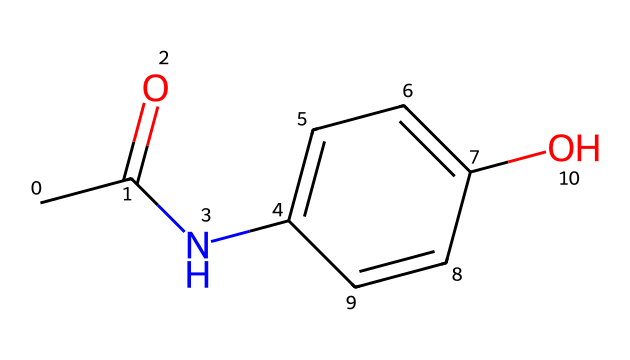What is the molecular formula of this compound? The molecular formula can be determined by counting the number of each type of atom in the SMILES representation. The structure contains 9 carbon atoms, 9 hydrogen atoms, 1 nitrogen atom, and 1 oxygen atom. Therefore, the molecular formula is C9H9NO.
Answer: C9H9NO How many rings are present in the structure? To identify rings, one must look for atoms connected to form a closed loop in the structure. The structure shows one six-membered aromatic ring indicated by the presence of alternating double bonds in the carbon chain. Therefore, there is one ring.
Answer: 1 What type of functional groups are present in this molecule? By analyzing the structure, one can identify the functional groups: there is an amide functional group (from the -NC=O part) and a phenolic hydroxyl group (from the -OH attachment). Hence, the functional groups present are an amide and a phenol.
Answer: amide and phenol What is the predicted solubility of this drug in water? The presence of the hydroxyl group (phenolic) typically increases solubility in polar solvents like water. However, the lipophilic alkyl portion may reduce it somewhat, though due to the hydroxyl group, it is still expected to be moderately soluble. Thus, it would likely be soluble in water.
Answer: soluble What is the primary mechanism of action of paracetamol? Paracetamol primarily acts by inhibiting prostaglandin synthesis in the central nervous system (CNS), primarily affecting cyclooxygenase (COX) enzymes. This reduces pain and fever. The reasoning involves understanding how paracetamol interacts with enzymes to modulate pain signaling.
Answer: COX inhibition What does the presence of nitrogen in this structure suggest about its pharmacokinetics? The presence of nitrogen typically indicates that this drug may undergo metabolic processes involving N-dealkylation or hydroxylation, potentially affecting its clearance rate. Nitrogen can also impact the binding affinity to receptors or enzymes. Thus, nitrogen suggests a specific metabolic pathway affecting pharmacokinetics.
Answer: metabolic complexity 